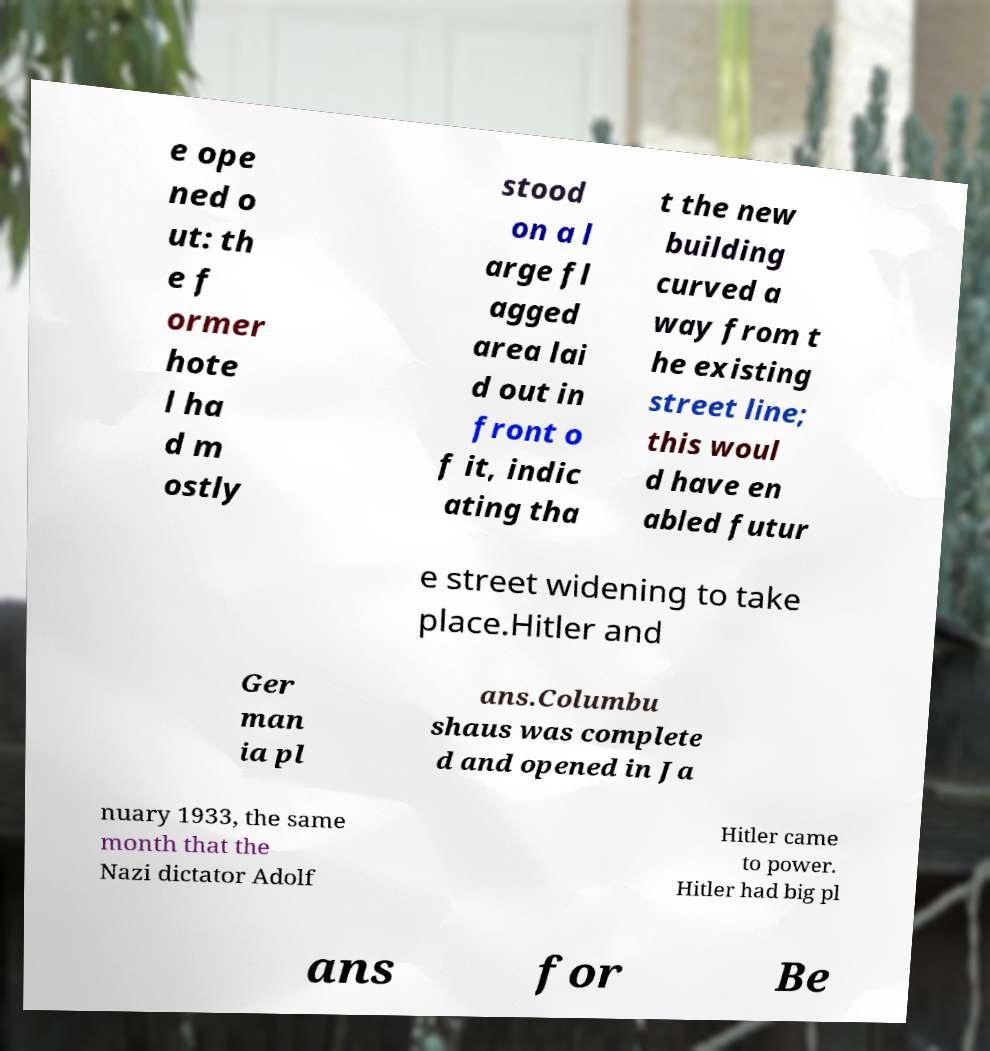Can you read and provide the text displayed in the image?This photo seems to have some interesting text. Can you extract and type it out for me? e ope ned o ut: th e f ormer hote l ha d m ostly stood on a l arge fl agged area lai d out in front o f it, indic ating tha t the new building curved a way from t he existing street line; this woul d have en abled futur e street widening to take place.Hitler and Ger man ia pl ans.Columbu shaus was complete d and opened in Ja nuary 1933, the same month that the Nazi dictator Adolf Hitler came to power. Hitler had big pl ans for Be 